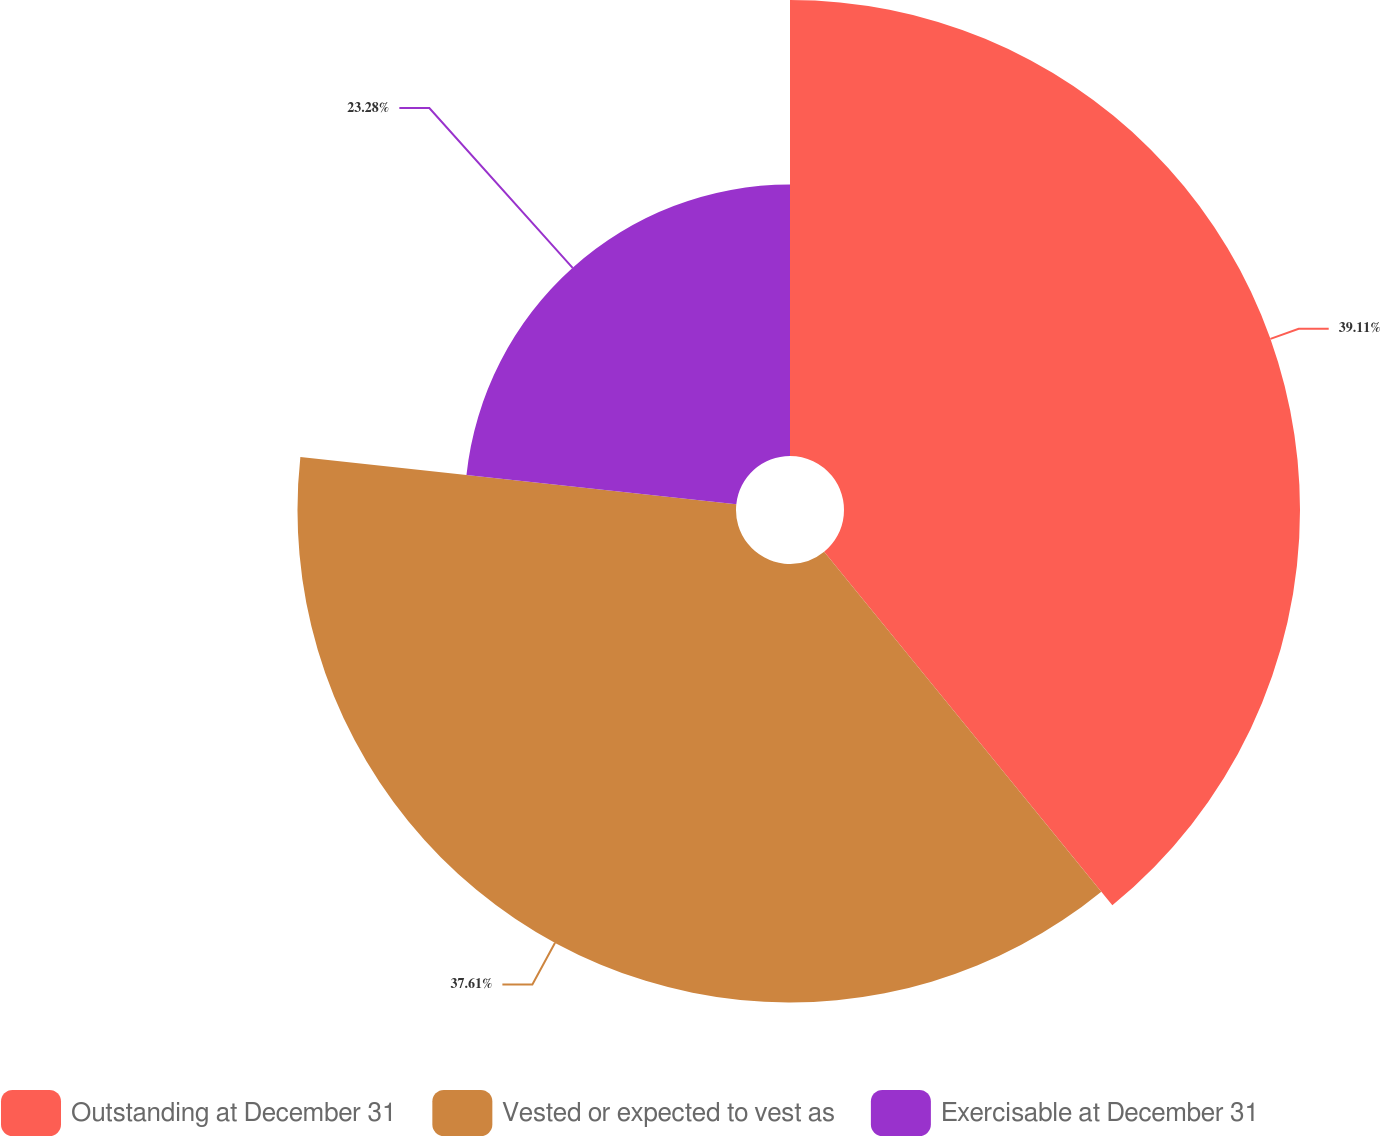Convert chart. <chart><loc_0><loc_0><loc_500><loc_500><pie_chart><fcel>Outstanding at December 31<fcel>Vested or expected to vest as<fcel>Exercisable at December 31<nl><fcel>39.11%<fcel>37.61%<fcel>23.28%<nl></chart> 